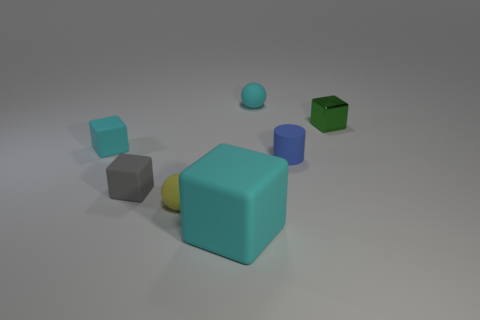Is there an object that appears to be floating? Yes, the small blue sphere seems to be elevated above the rest, giving the impression that it's floating in mid-air. 